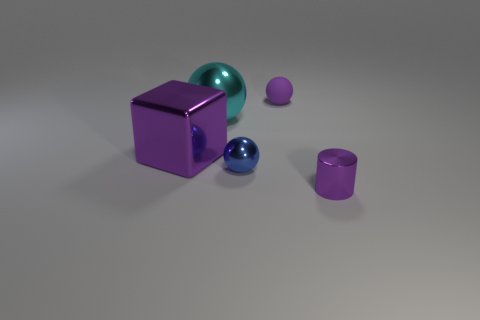Add 2 large metal blocks. How many objects exist? 7 Subtract all cylinders. How many objects are left? 4 Subtract all cylinders. Subtract all big cyan metal spheres. How many objects are left? 3 Add 1 small metal things. How many small metal things are left? 3 Add 2 cylinders. How many cylinders exist? 3 Subtract 0 yellow blocks. How many objects are left? 5 